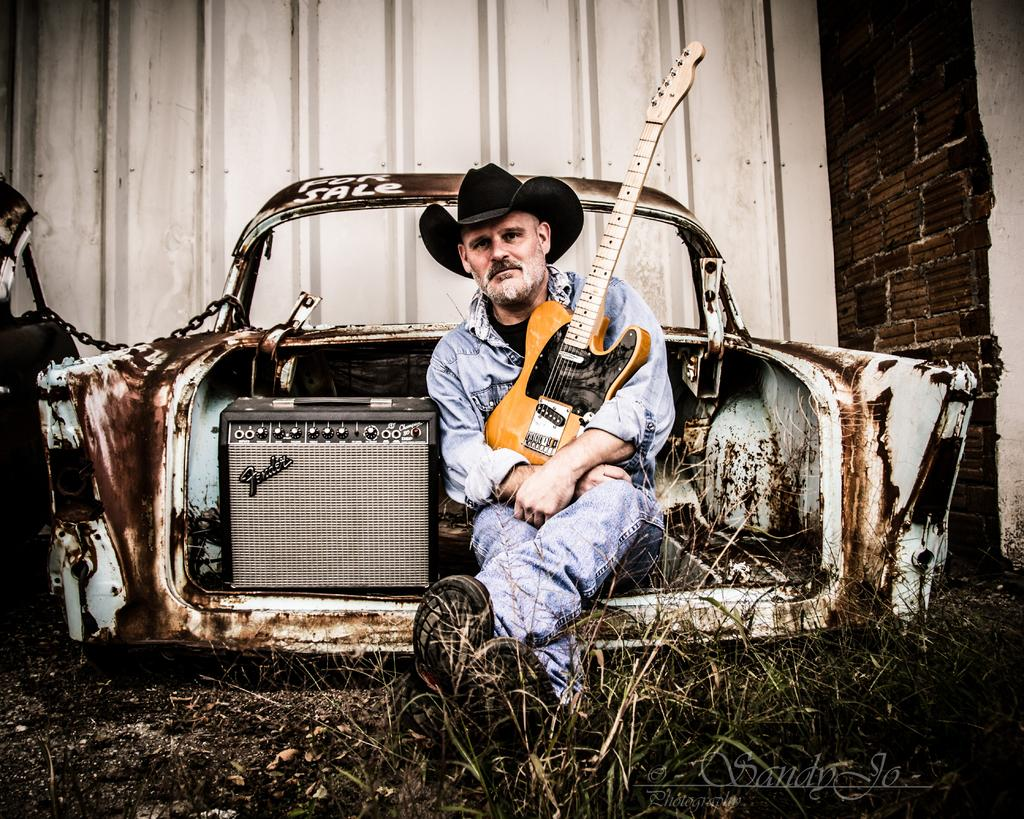Who is present in the image? There is a man in the image. What is the man doing in the image? The man is sitting in a car. Can you describe the car in the image? The car is old and rusted. What is the man holding in the image? The man is holding a guitar. How many dimes can be seen on the car's dashboard in the image? There are no dimes visible on the car's dashboard in the image. Is the man in the image performing a twist dance move? There is no indication of a twist dance move in the image; the man is simply sitting in the car holding a guitar. 